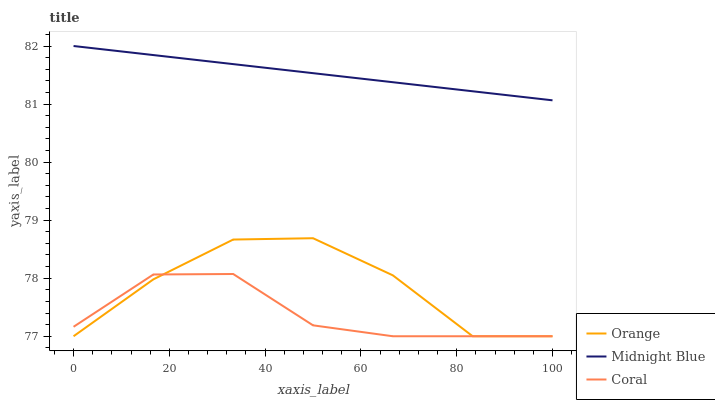Does Coral have the minimum area under the curve?
Answer yes or no. Yes. Does Midnight Blue have the maximum area under the curve?
Answer yes or no. Yes. Does Midnight Blue have the minimum area under the curve?
Answer yes or no. No. Does Coral have the maximum area under the curve?
Answer yes or no. No. Is Midnight Blue the smoothest?
Answer yes or no. Yes. Is Orange the roughest?
Answer yes or no. Yes. Is Coral the smoothest?
Answer yes or no. No. Is Coral the roughest?
Answer yes or no. No. Does Orange have the lowest value?
Answer yes or no. Yes. Does Midnight Blue have the lowest value?
Answer yes or no. No. Does Midnight Blue have the highest value?
Answer yes or no. Yes. Does Coral have the highest value?
Answer yes or no. No. Is Orange less than Midnight Blue?
Answer yes or no. Yes. Is Midnight Blue greater than Coral?
Answer yes or no. Yes. Does Orange intersect Coral?
Answer yes or no. Yes. Is Orange less than Coral?
Answer yes or no. No. Is Orange greater than Coral?
Answer yes or no. No. Does Orange intersect Midnight Blue?
Answer yes or no. No. 